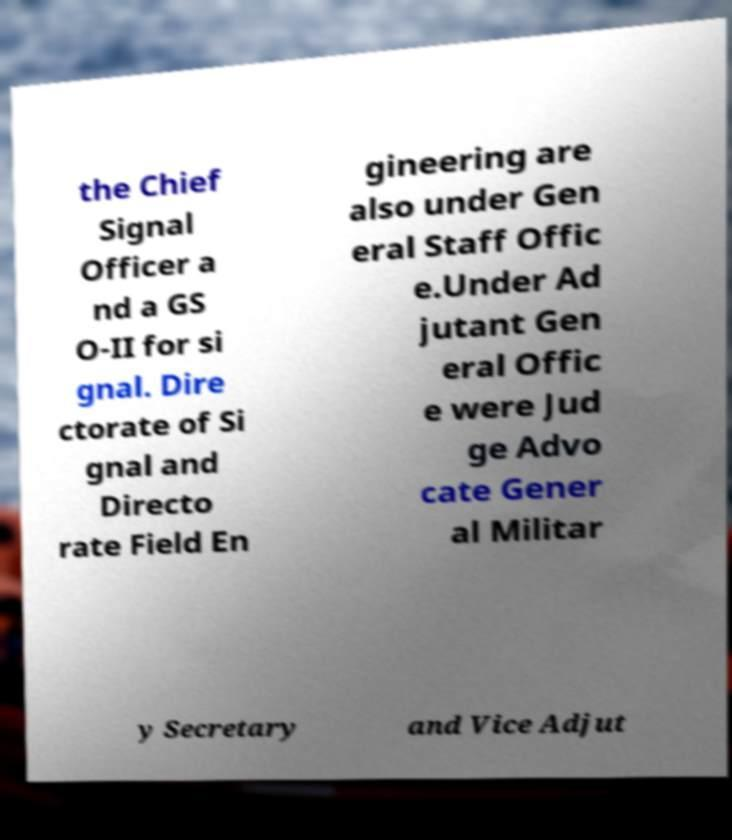Can you accurately transcribe the text from the provided image for me? the Chief Signal Officer a nd a GS O-II for si gnal. Dire ctorate of Si gnal and Directo rate Field En gineering are also under Gen eral Staff Offic e.Under Ad jutant Gen eral Offic e were Jud ge Advo cate Gener al Militar y Secretary and Vice Adjut 